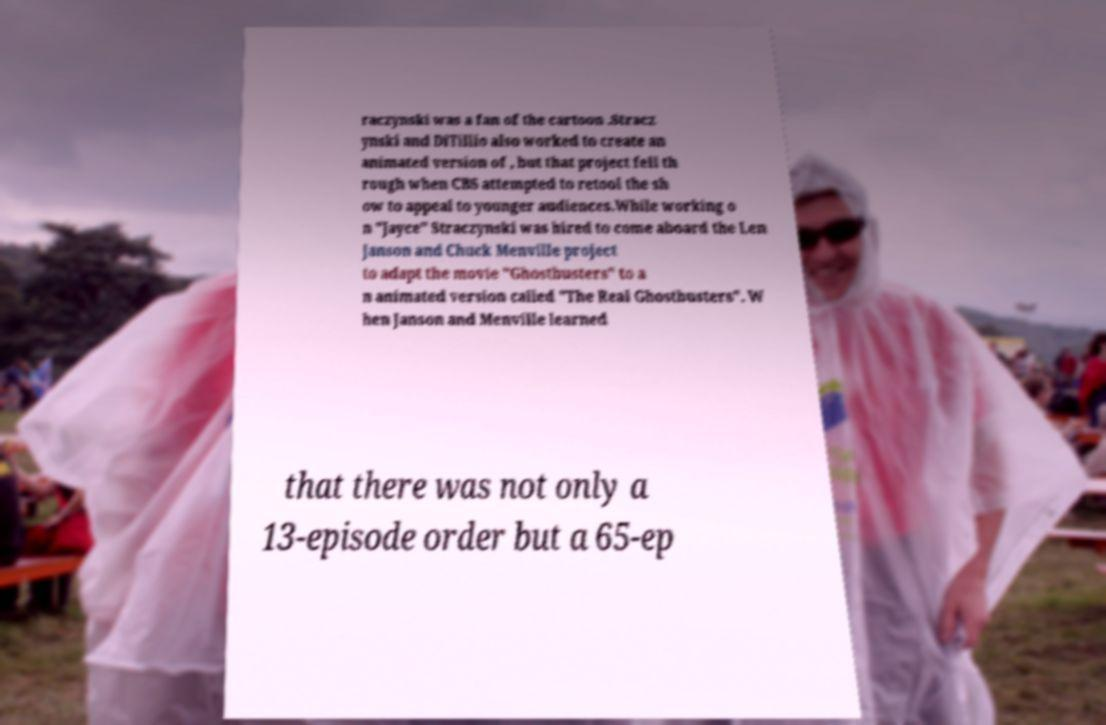Could you assist in decoding the text presented in this image and type it out clearly? raczynski was a fan of the cartoon .Stracz ynski and DiTillio also worked to create an animated version of , but that project fell th rough when CBS attempted to retool the sh ow to appeal to younger audiences.While working o n "Jayce" Straczynski was hired to come aboard the Len Janson and Chuck Menville project to adapt the movie "Ghostbusters" to a n animated version called "The Real Ghostbusters". W hen Janson and Menville learned that there was not only a 13-episode order but a 65-ep 